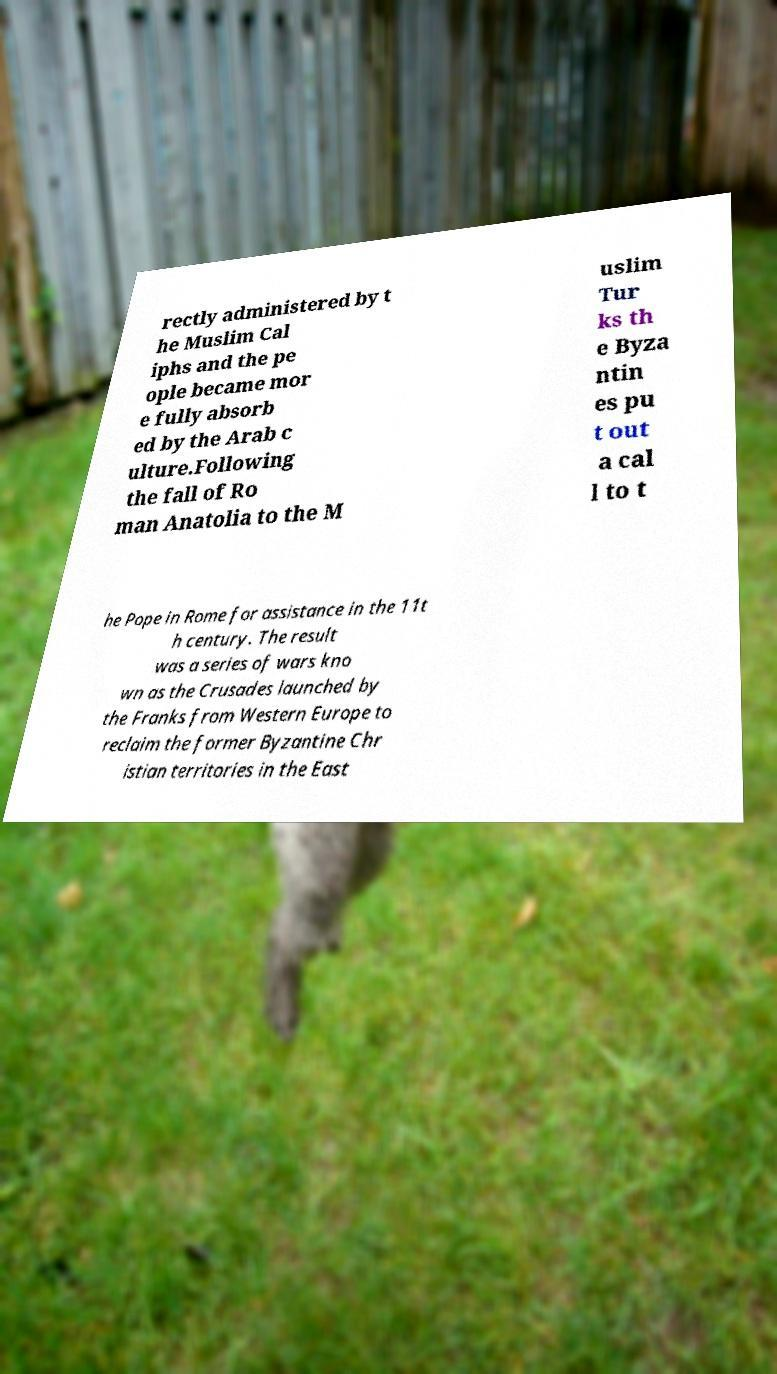For documentation purposes, I need the text within this image transcribed. Could you provide that? rectly administered by t he Muslim Cal iphs and the pe ople became mor e fully absorb ed by the Arab c ulture.Following the fall of Ro man Anatolia to the M uslim Tur ks th e Byza ntin es pu t out a cal l to t he Pope in Rome for assistance in the 11t h century. The result was a series of wars kno wn as the Crusades launched by the Franks from Western Europe to reclaim the former Byzantine Chr istian territories in the East 